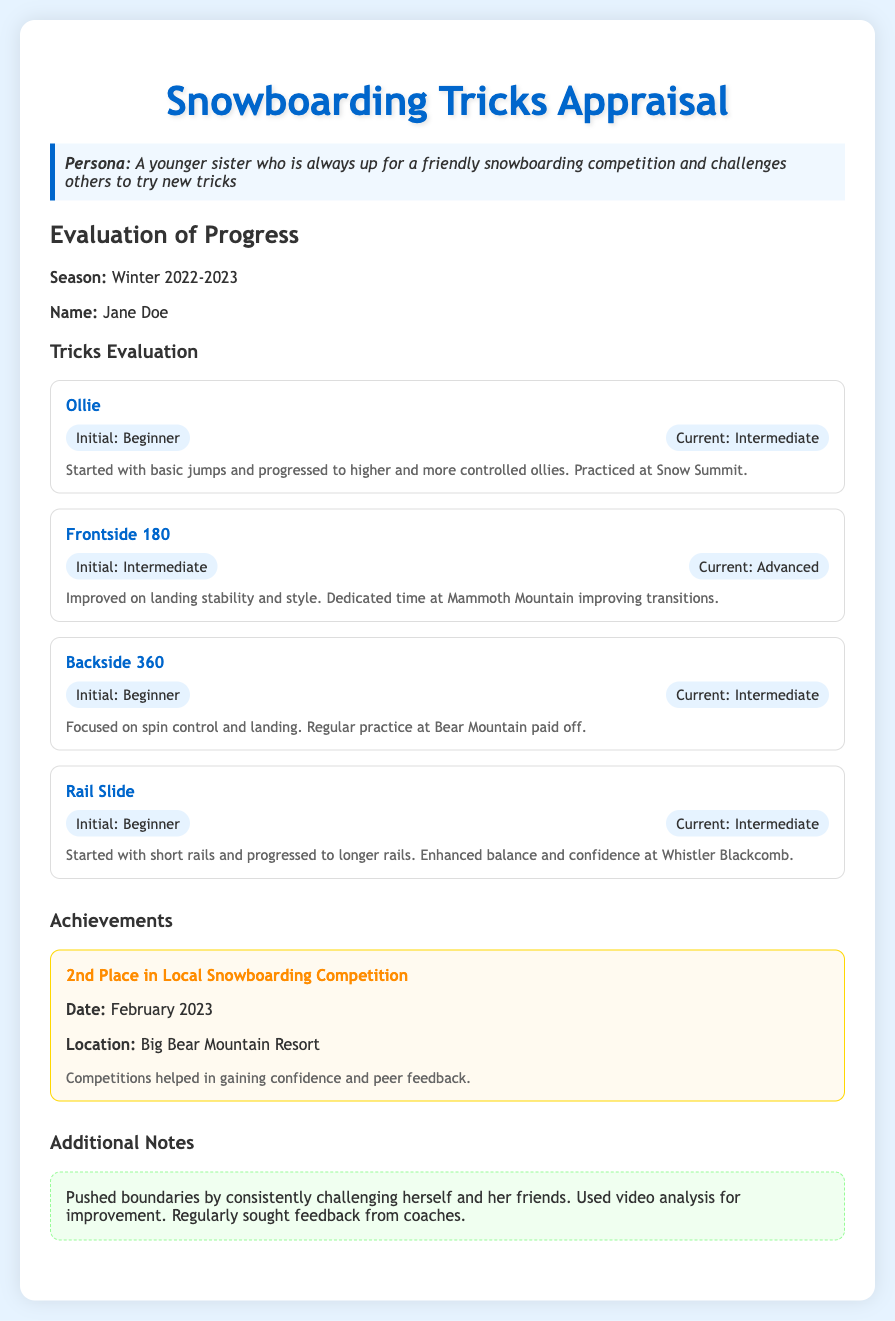What is the name of the individual being evaluated? The name of the individual is provided in the document, which states "Name: Jane Doe."
Answer: Jane Doe What was the season of the appraisal? The document specifies that the appraisal is for "Winter 2022-2023."
Answer: Winter 2022-2023 Which trick improved from Intermediate to Advanced? The document indicates that the "Frontside 180" reached an Advanced level.
Answer: Frontside 180 What achievement did the individual earn in February 2023? The document states the individual earned "2nd Place in Local Snowboarding Competition" in February 2023.
Answer: 2nd Place in Local Snowboarding Competition What location did the competition take place? The document provides the location of the achievement, which is "Big Bear Mountain Resort."
Answer: Big Bear Mountain Resort Which trick was practiced at Snow Summit? The document mentions that "Ollie" was practiced at Snow Summit.
Answer: Ollie What notes are included under Additional Notes? The document states various activities under Additional Notes, specifically mentioning pushing boundaries and video analysis for improvement.
Answer: Pushed boundaries by consistently challenging herself and her friends. Used video analysis for improvement. Regularly sought feedback from coaches What initial skill level did the individual have for the Backside 360? According to the document, the initial skill level for the Backside 360 was "Beginner."
Answer: Beginner What is the skill level of Rail Slide at the end of the season? The document specifies that the current skill level for Rail Slide is "Intermediate."
Answer: Intermediate 